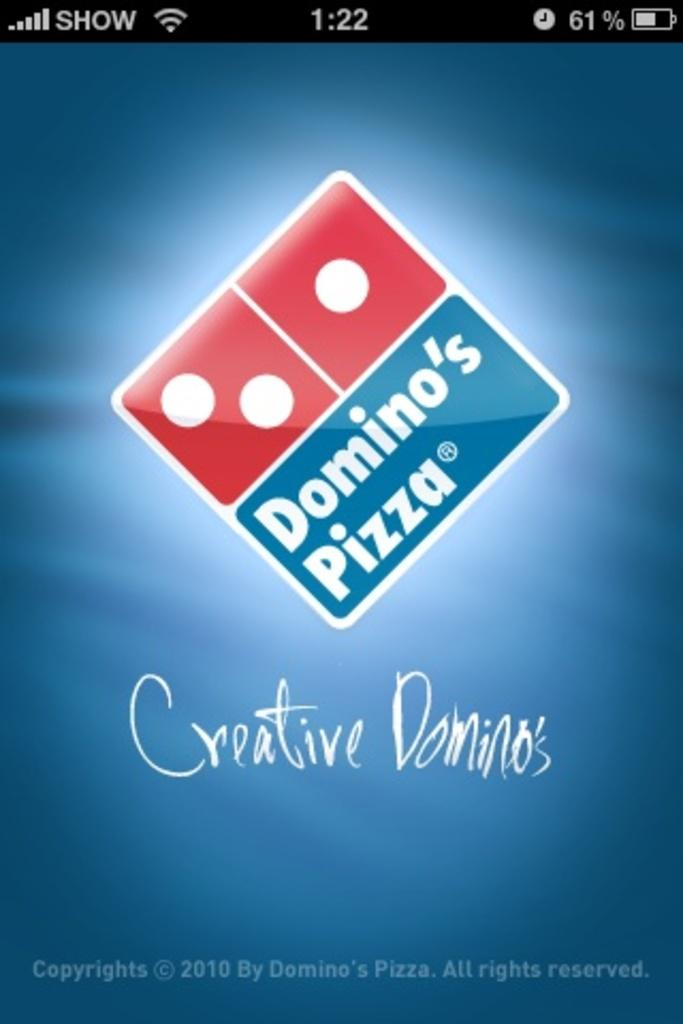What is the main subject of the image? The main subject of the image is a mobile screen. What can be seen on the mobile screen? There is a logo and text visible on the mobile screen. What type of paper can be seen on the chair in the image? There is no paper or chair present in the image; it only features a mobile screen. What kind of record is being played on the mobile screen in the image? There is no record being played on the mobile screen in the image; it only displays a logo and text. 